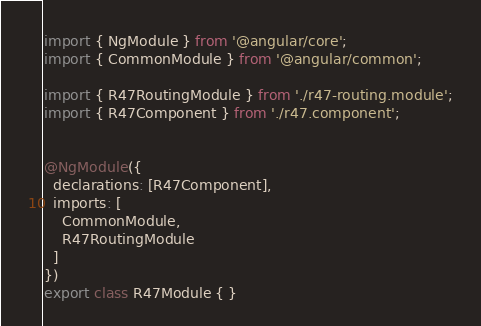Convert code to text. <code><loc_0><loc_0><loc_500><loc_500><_TypeScript_>import { NgModule } from '@angular/core';
import { CommonModule } from '@angular/common';

import { R47RoutingModule } from './r47-routing.module';
import { R47Component } from './r47.component';


@NgModule({
  declarations: [R47Component],
  imports: [
    CommonModule,
    R47RoutingModule
  ]
})
export class R47Module { }
</code> 